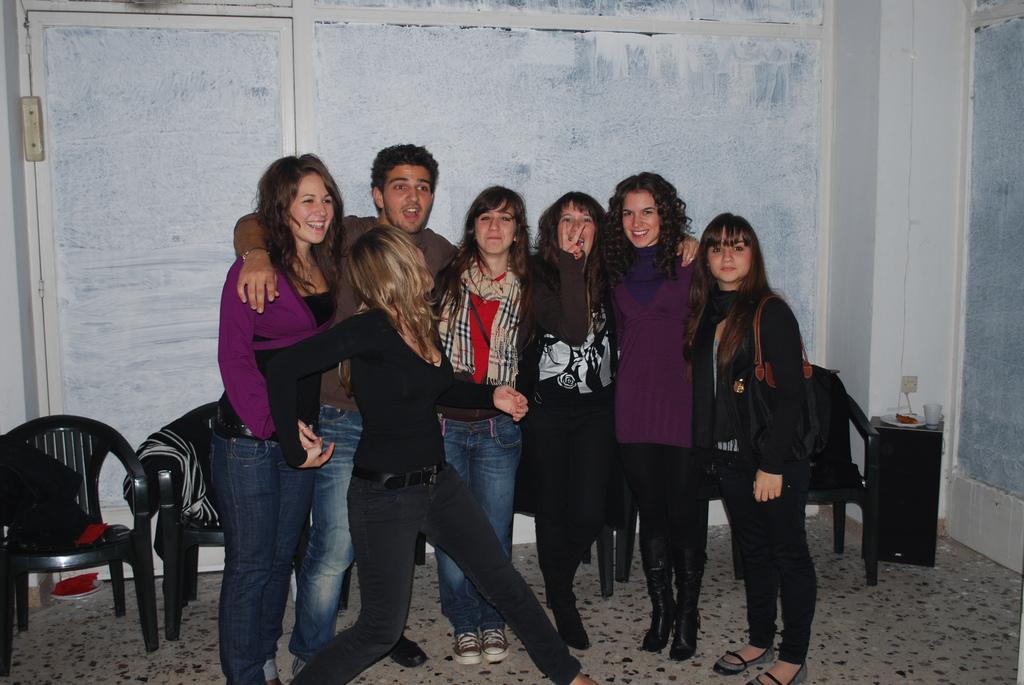Describe this image in one or two sentences. In this image there are group o f persons standing on the floor ,back side of them there are the chairs and on the chairs there are the clothes and back side of them there is a wall and all the people are smiling ,and on the right side a woman wearing a black color shirt and she wearing a hand bag on her shoulder and back side of her there is a table ,beside that there is a another table ,on the table there is a glass a and plate. 